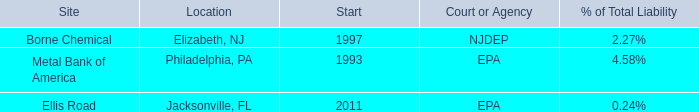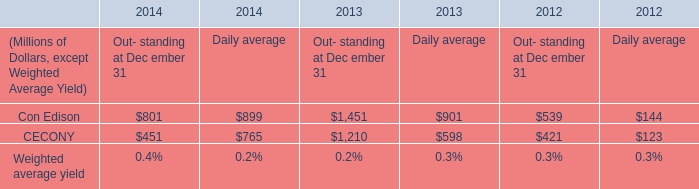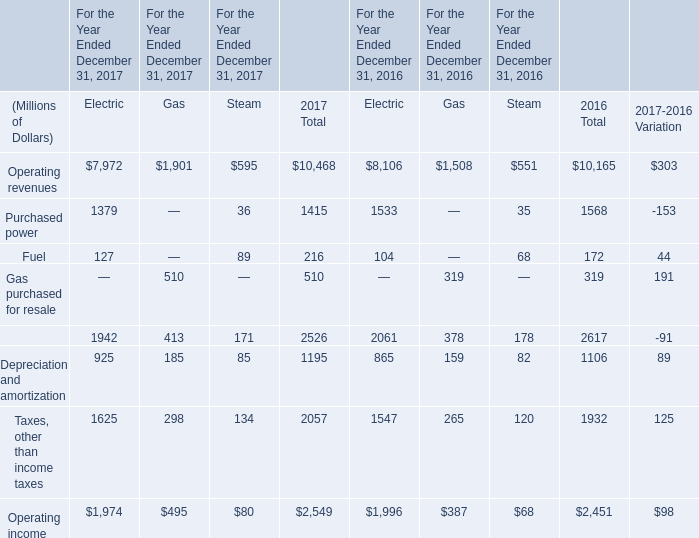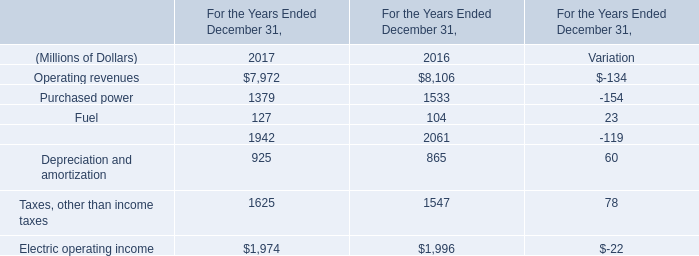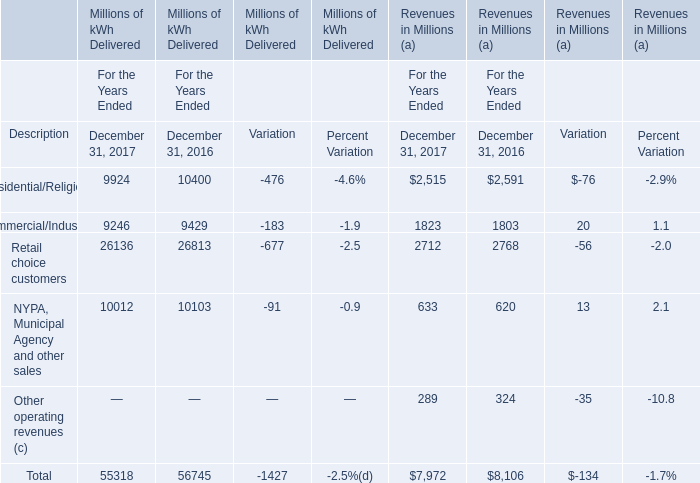What's the increasing rate of Taxes, other than income taxes in 2017? 
Computations: ((1625 - 1547) / 1625)
Answer: 0.048. 